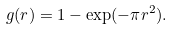<formula> <loc_0><loc_0><loc_500><loc_500>g ( r ) = 1 - \exp ( - \pi r ^ { 2 } ) .</formula> 